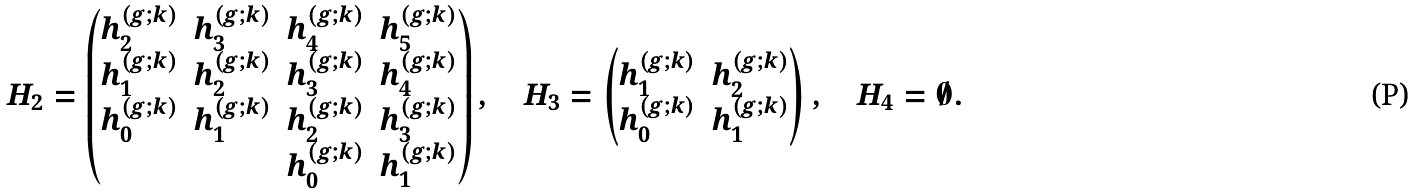Convert formula to latex. <formula><loc_0><loc_0><loc_500><loc_500>H _ { 2 } = \begin{pmatrix} h _ { 2 } ^ { ( g ; k ) } & h _ { 3 } ^ { ( g ; k ) } & h _ { 4 } ^ { ( g ; k ) } & h _ { 5 } ^ { ( g ; k ) } \\ h _ { 1 } ^ { ( g ; k ) } & h _ { 2 } ^ { ( g ; k ) } & h _ { 3 } ^ { ( g ; k ) } & h _ { 4 } ^ { ( g ; k ) } \\ h _ { 0 } ^ { ( g ; k ) } & h _ { 1 } ^ { ( g ; k ) } & h _ { 2 } ^ { ( g ; k ) } & h _ { 3 } ^ { ( g ; k ) } \\ & & h _ { 0 } ^ { ( g ; k ) } & h _ { 1 } ^ { ( g ; k ) } \end{pmatrix} , \quad H _ { 3 } = \begin{pmatrix} h _ { 1 } ^ { ( g ; k ) } & h _ { 2 } ^ { ( g ; k ) } \\ h _ { 0 } ^ { ( g ; k ) } & h _ { 1 } ^ { ( g ; k ) } \end{pmatrix} , \quad H _ { 4 } = \emptyset .</formula> 